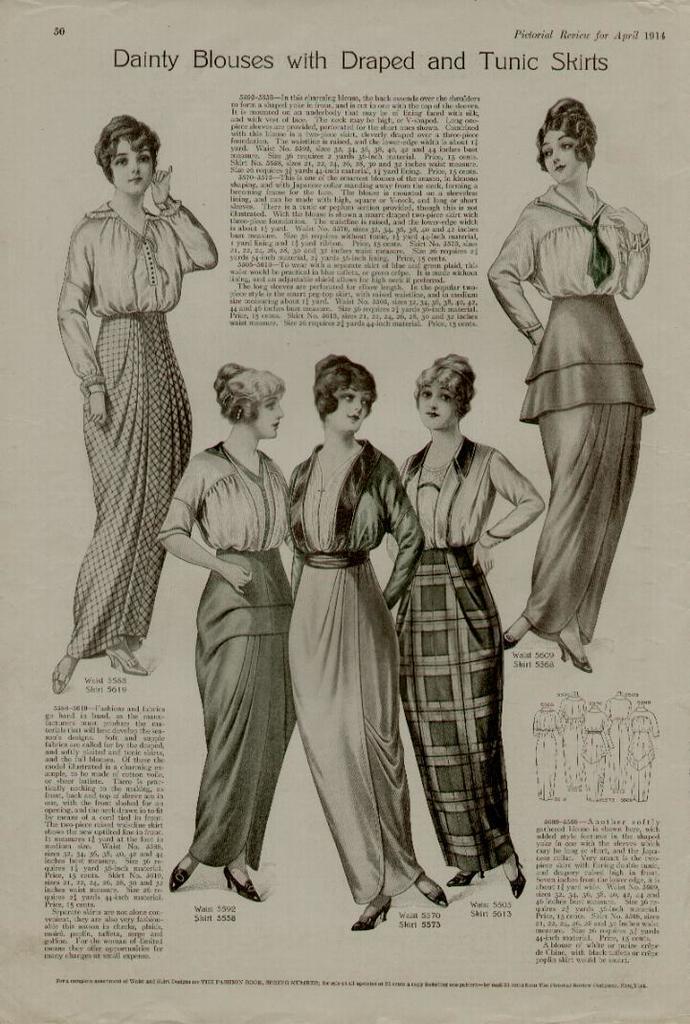Please provide a concise description of this image. In this image I can see few persons standing and I can see something written on the image and the image is in black and white. 